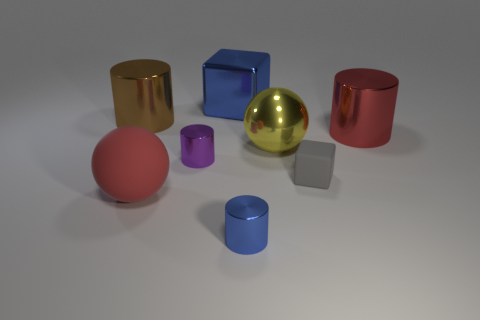How many large things are either red balls or purple cylinders?
Your response must be concise. 1. Is the number of yellow objects in front of the big yellow ball the same as the number of small blue metallic objects in front of the small blue shiny thing?
Give a very brief answer. Yes. What number of other objects are the same color as the small rubber thing?
Provide a succinct answer. 0. Are there the same number of tiny purple metal objects to the right of the big matte sphere and big brown metallic cylinders?
Ensure brevity in your answer.  Yes. Does the red metal object have the same size as the blue block?
Offer a very short reply. Yes. The big thing that is behind the red metal object and on the right side of the big rubber object is made of what material?
Make the answer very short. Metal. What number of small shiny objects have the same shape as the tiny gray rubber thing?
Make the answer very short. 0. What is the material of the cylinder behind the big red metallic object?
Offer a very short reply. Metal. Is the number of large cubes to the right of the shiny block less than the number of red objects?
Provide a succinct answer. Yes. Do the purple object and the large brown thing have the same shape?
Your response must be concise. Yes. 